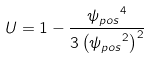<formula> <loc_0><loc_0><loc_500><loc_500>U = 1 - \frac { { \psi _ { p o s } } ^ { 4 } } { 3 \left ( { \psi _ { p o s } } ^ { 2 } \right ) ^ { 2 } }</formula> 